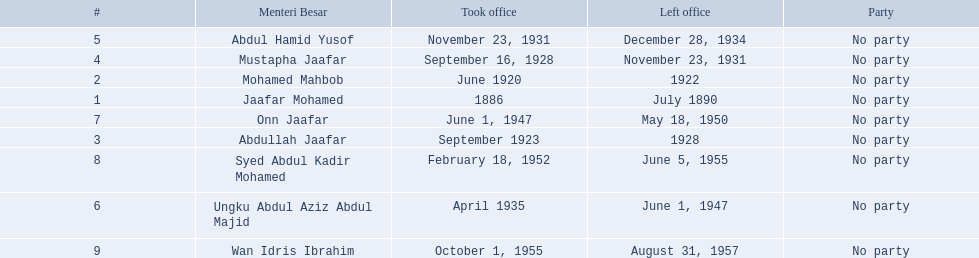What are all the people that were menteri besar of johor? Jaafar Mohamed, Mohamed Mahbob, Abdullah Jaafar, Mustapha Jaafar, Abdul Hamid Yusof, Ungku Abdul Aziz Abdul Majid, Onn Jaafar, Syed Abdul Kadir Mohamed, Wan Idris Ibrahim. Who ruled the longest? Ungku Abdul Aziz Abdul Majid. 